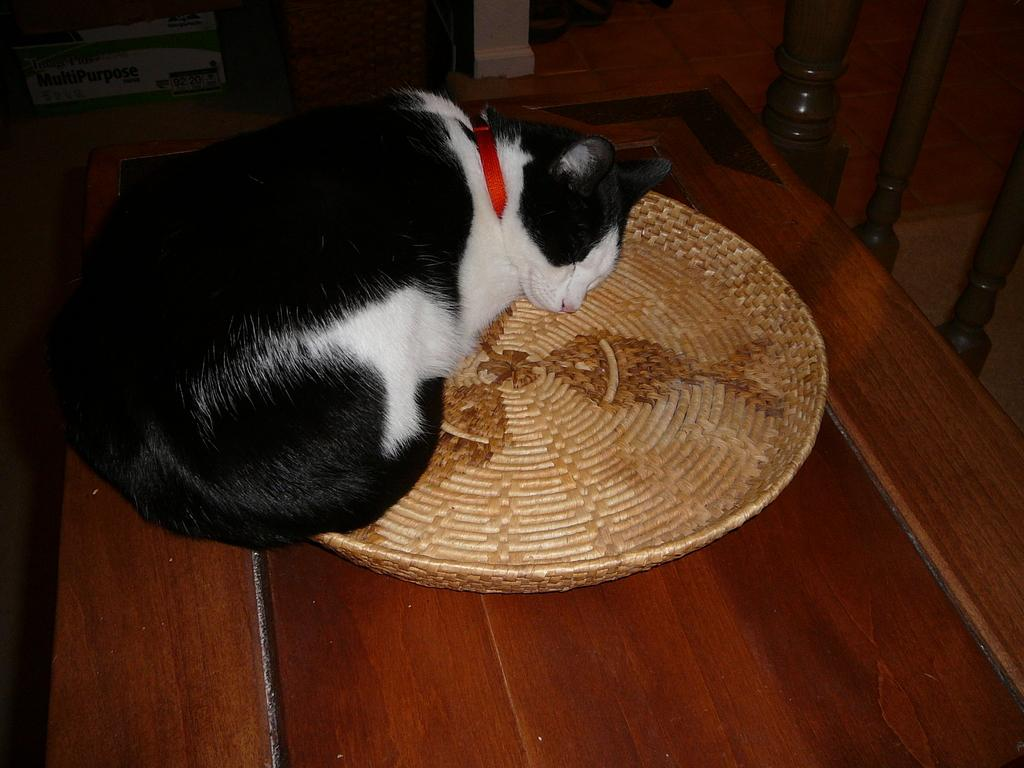What animal is present in the image? There is a cat in the image. What is the cat doing in the image? The cat is sleeping. Where is the cat located in the image? The cat is on a basket. What is the color scheme of the image? The image is in black and white. What type of fruit is the monkey holding in the image? There is no monkey or fruit present in the image; it features a cat sleeping on a basket. 